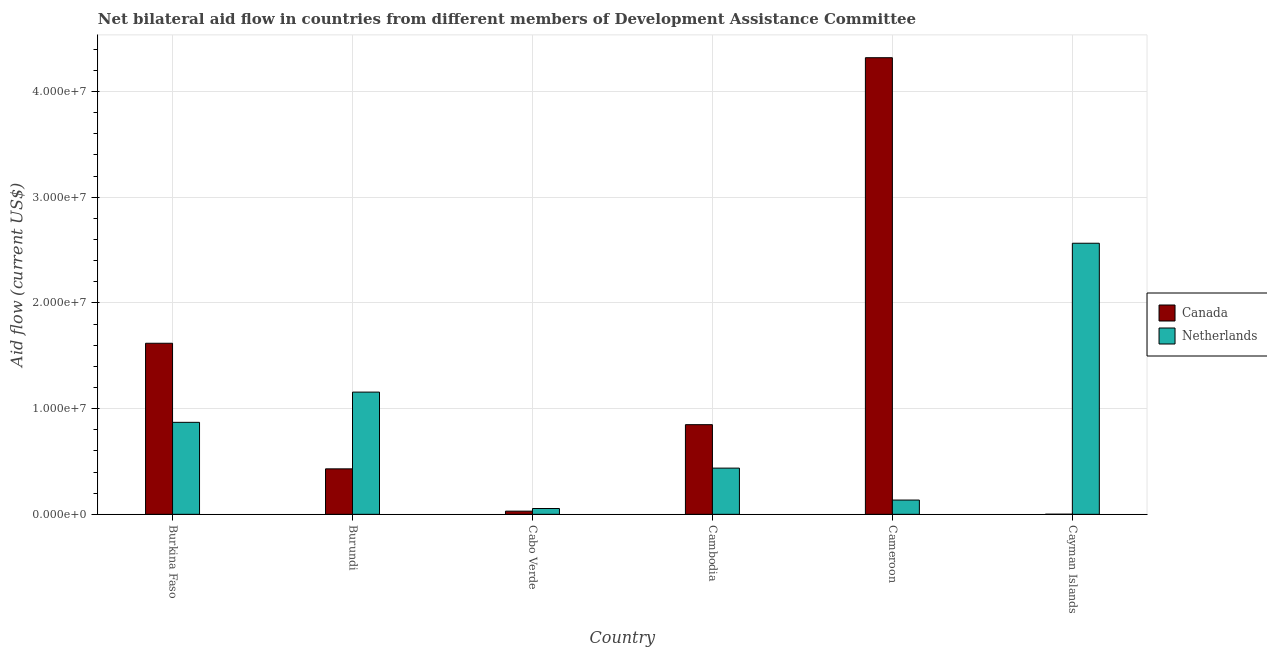How many different coloured bars are there?
Provide a succinct answer. 2. How many groups of bars are there?
Make the answer very short. 6. Are the number of bars per tick equal to the number of legend labels?
Give a very brief answer. Yes. Are the number of bars on each tick of the X-axis equal?
Your answer should be compact. Yes. What is the label of the 2nd group of bars from the left?
Provide a short and direct response. Burundi. What is the amount of aid given by netherlands in Cameroon?
Provide a short and direct response. 1.35e+06. Across all countries, what is the maximum amount of aid given by canada?
Give a very brief answer. 4.32e+07. Across all countries, what is the minimum amount of aid given by canada?
Offer a very short reply. 10000. In which country was the amount of aid given by canada maximum?
Make the answer very short. Cameroon. In which country was the amount of aid given by netherlands minimum?
Provide a short and direct response. Cabo Verde. What is the total amount of aid given by netherlands in the graph?
Make the answer very short. 5.22e+07. What is the difference between the amount of aid given by canada in Burkina Faso and that in Burundi?
Offer a terse response. 1.19e+07. What is the difference between the amount of aid given by canada in Burkina Faso and the amount of aid given by netherlands in Cabo Verde?
Offer a terse response. 1.56e+07. What is the average amount of aid given by netherlands per country?
Make the answer very short. 8.70e+06. What is the difference between the amount of aid given by netherlands and amount of aid given by canada in Burkina Faso?
Your answer should be very brief. -7.48e+06. What is the ratio of the amount of aid given by canada in Cambodia to that in Cameroon?
Give a very brief answer. 0.2. What is the difference between the highest and the second highest amount of aid given by canada?
Your answer should be very brief. 2.70e+07. What is the difference between the highest and the lowest amount of aid given by canada?
Your answer should be very brief. 4.32e+07. In how many countries, is the amount of aid given by canada greater than the average amount of aid given by canada taken over all countries?
Keep it short and to the point. 2. Is the sum of the amount of aid given by netherlands in Burkina Faso and Cambodia greater than the maximum amount of aid given by canada across all countries?
Keep it short and to the point. No. What does the 2nd bar from the left in Cayman Islands represents?
Make the answer very short. Netherlands. Are all the bars in the graph horizontal?
Provide a short and direct response. No. Are the values on the major ticks of Y-axis written in scientific E-notation?
Give a very brief answer. Yes. Does the graph contain any zero values?
Keep it short and to the point. No. Where does the legend appear in the graph?
Ensure brevity in your answer.  Center right. How many legend labels are there?
Make the answer very short. 2. What is the title of the graph?
Make the answer very short. Net bilateral aid flow in countries from different members of Development Assistance Committee. Does "Private consumption" appear as one of the legend labels in the graph?
Your answer should be compact. No. What is the label or title of the Y-axis?
Offer a terse response. Aid flow (current US$). What is the Aid flow (current US$) of Canada in Burkina Faso?
Give a very brief answer. 1.62e+07. What is the Aid flow (current US$) of Netherlands in Burkina Faso?
Offer a terse response. 8.70e+06. What is the Aid flow (current US$) of Canada in Burundi?
Provide a short and direct response. 4.30e+06. What is the Aid flow (current US$) in Netherlands in Burundi?
Ensure brevity in your answer.  1.16e+07. What is the Aid flow (current US$) of Canada in Cambodia?
Provide a short and direct response. 8.48e+06. What is the Aid flow (current US$) in Netherlands in Cambodia?
Provide a succinct answer. 4.37e+06. What is the Aid flow (current US$) of Canada in Cameroon?
Provide a short and direct response. 4.32e+07. What is the Aid flow (current US$) of Netherlands in Cameroon?
Provide a succinct answer. 1.35e+06. What is the Aid flow (current US$) of Netherlands in Cayman Islands?
Give a very brief answer. 2.56e+07. Across all countries, what is the maximum Aid flow (current US$) of Canada?
Keep it short and to the point. 4.32e+07. Across all countries, what is the maximum Aid flow (current US$) in Netherlands?
Offer a very short reply. 2.56e+07. What is the total Aid flow (current US$) in Canada in the graph?
Keep it short and to the point. 7.25e+07. What is the total Aid flow (current US$) in Netherlands in the graph?
Ensure brevity in your answer.  5.22e+07. What is the difference between the Aid flow (current US$) of Canada in Burkina Faso and that in Burundi?
Make the answer very short. 1.19e+07. What is the difference between the Aid flow (current US$) of Netherlands in Burkina Faso and that in Burundi?
Provide a short and direct response. -2.86e+06. What is the difference between the Aid flow (current US$) of Canada in Burkina Faso and that in Cabo Verde?
Give a very brief answer. 1.59e+07. What is the difference between the Aid flow (current US$) in Netherlands in Burkina Faso and that in Cabo Verde?
Ensure brevity in your answer.  8.15e+06. What is the difference between the Aid flow (current US$) in Canada in Burkina Faso and that in Cambodia?
Your response must be concise. 7.70e+06. What is the difference between the Aid flow (current US$) in Netherlands in Burkina Faso and that in Cambodia?
Offer a very short reply. 4.33e+06. What is the difference between the Aid flow (current US$) of Canada in Burkina Faso and that in Cameroon?
Ensure brevity in your answer.  -2.70e+07. What is the difference between the Aid flow (current US$) of Netherlands in Burkina Faso and that in Cameroon?
Provide a succinct answer. 7.35e+06. What is the difference between the Aid flow (current US$) in Canada in Burkina Faso and that in Cayman Islands?
Your answer should be compact. 1.62e+07. What is the difference between the Aid flow (current US$) in Netherlands in Burkina Faso and that in Cayman Islands?
Give a very brief answer. -1.69e+07. What is the difference between the Aid flow (current US$) of Netherlands in Burundi and that in Cabo Verde?
Offer a terse response. 1.10e+07. What is the difference between the Aid flow (current US$) in Canada in Burundi and that in Cambodia?
Make the answer very short. -4.18e+06. What is the difference between the Aid flow (current US$) of Netherlands in Burundi and that in Cambodia?
Your answer should be compact. 7.19e+06. What is the difference between the Aid flow (current US$) in Canada in Burundi and that in Cameroon?
Ensure brevity in your answer.  -3.89e+07. What is the difference between the Aid flow (current US$) in Netherlands in Burundi and that in Cameroon?
Your response must be concise. 1.02e+07. What is the difference between the Aid flow (current US$) of Canada in Burundi and that in Cayman Islands?
Give a very brief answer. 4.29e+06. What is the difference between the Aid flow (current US$) of Netherlands in Burundi and that in Cayman Islands?
Keep it short and to the point. -1.41e+07. What is the difference between the Aid flow (current US$) in Canada in Cabo Verde and that in Cambodia?
Provide a short and direct response. -8.18e+06. What is the difference between the Aid flow (current US$) in Netherlands in Cabo Verde and that in Cambodia?
Ensure brevity in your answer.  -3.82e+06. What is the difference between the Aid flow (current US$) in Canada in Cabo Verde and that in Cameroon?
Make the answer very short. -4.29e+07. What is the difference between the Aid flow (current US$) in Netherlands in Cabo Verde and that in Cameroon?
Your answer should be very brief. -8.00e+05. What is the difference between the Aid flow (current US$) of Netherlands in Cabo Verde and that in Cayman Islands?
Your answer should be compact. -2.51e+07. What is the difference between the Aid flow (current US$) in Canada in Cambodia and that in Cameroon?
Provide a short and direct response. -3.47e+07. What is the difference between the Aid flow (current US$) in Netherlands in Cambodia and that in Cameroon?
Offer a very short reply. 3.02e+06. What is the difference between the Aid flow (current US$) of Canada in Cambodia and that in Cayman Islands?
Offer a very short reply. 8.47e+06. What is the difference between the Aid flow (current US$) in Netherlands in Cambodia and that in Cayman Islands?
Your answer should be very brief. -2.13e+07. What is the difference between the Aid flow (current US$) in Canada in Cameroon and that in Cayman Islands?
Provide a short and direct response. 4.32e+07. What is the difference between the Aid flow (current US$) of Netherlands in Cameroon and that in Cayman Islands?
Offer a very short reply. -2.43e+07. What is the difference between the Aid flow (current US$) in Canada in Burkina Faso and the Aid flow (current US$) in Netherlands in Burundi?
Your response must be concise. 4.62e+06. What is the difference between the Aid flow (current US$) of Canada in Burkina Faso and the Aid flow (current US$) of Netherlands in Cabo Verde?
Your answer should be compact. 1.56e+07. What is the difference between the Aid flow (current US$) of Canada in Burkina Faso and the Aid flow (current US$) of Netherlands in Cambodia?
Your answer should be very brief. 1.18e+07. What is the difference between the Aid flow (current US$) of Canada in Burkina Faso and the Aid flow (current US$) of Netherlands in Cameroon?
Provide a short and direct response. 1.48e+07. What is the difference between the Aid flow (current US$) in Canada in Burkina Faso and the Aid flow (current US$) in Netherlands in Cayman Islands?
Provide a short and direct response. -9.46e+06. What is the difference between the Aid flow (current US$) of Canada in Burundi and the Aid flow (current US$) of Netherlands in Cabo Verde?
Your answer should be compact. 3.75e+06. What is the difference between the Aid flow (current US$) of Canada in Burundi and the Aid flow (current US$) of Netherlands in Cameroon?
Keep it short and to the point. 2.95e+06. What is the difference between the Aid flow (current US$) of Canada in Burundi and the Aid flow (current US$) of Netherlands in Cayman Islands?
Make the answer very short. -2.13e+07. What is the difference between the Aid flow (current US$) of Canada in Cabo Verde and the Aid flow (current US$) of Netherlands in Cambodia?
Give a very brief answer. -4.07e+06. What is the difference between the Aid flow (current US$) of Canada in Cabo Verde and the Aid flow (current US$) of Netherlands in Cameroon?
Offer a very short reply. -1.05e+06. What is the difference between the Aid flow (current US$) in Canada in Cabo Verde and the Aid flow (current US$) in Netherlands in Cayman Islands?
Give a very brief answer. -2.53e+07. What is the difference between the Aid flow (current US$) in Canada in Cambodia and the Aid flow (current US$) in Netherlands in Cameroon?
Your answer should be compact. 7.13e+06. What is the difference between the Aid flow (current US$) of Canada in Cambodia and the Aid flow (current US$) of Netherlands in Cayman Islands?
Ensure brevity in your answer.  -1.72e+07. What is the difference between the Aid flow (current US$) in Canada in Cameroon and the Aid flow (current US$) in Netherlands in Cayman Islands?
Provide a short and direct response. 1.76e+07. What is the average Aid flow (current US$) of Canada per country?
Your response must be concise. 1.21e+07. What is the average Aid flow (current US$) in Netherlands per country?
Ensure brevity in your answer.  8.70e+06. What is the difference between the Aid flow (current US$) of Canada and Aid flow (current US$) of Netherlands in Burkina Faso?
Offer a terse response. 7.48e+06. What is the difference between the Aid flow (current US$) in Canada and Aid flow (current US$) in Netherlands in Burundi?
Make the answer very short. -7.26e+06. What is the difference between the Aid flow (current US$) of Canada and Aid flow (current US$) of Netherlands in Cabo Verde?
Offer a terse response. -2.50e+05. What is the difference between the Aid flow (current US$) of Canada and Aid flow (current US$) of Netherlands in Cambodia?
Offer a very short reply. 4.11e+06. What is the difference between the Aid flow (current US$) of Canada and Aid flow (current US$) of Netherlands in Cameroon?
Give a very brief answer. 4.18e+07. What is the difference between the Aid flow (current US$) of Canada and Aid flow (current US$) of Netherlands in Cayman Islands?
Make the answer very short. -2.56e+07. What is the ratio of the Aid flow (current US$) of Canada in Burkina Faso to that in Burundi?
Offer a very short reply. 3.76. What is the ratio of the Aid flow (current US$) in Netherlands in Burkina Faso to that in Burundi?
Offer a terse response. 0.75. What is the ratio of the Aid flow (current US$) in Canada in Burkina Faso to that in Cabo Verde?
Your answer should be compact. 53.93. What is the ratio of the Aid flow (current US$) of Netherlands in Burkina Faso to that in Cabo Verde?
Your answer should be very brief. 15.82. What is the ratio of the Aid flow (current US$) in Canada in Burkina Faso to that in Cambodia?
Provide a short and direct response. 1.91. What is the ratio of the Aid flow (current US$) of Netherlands in Burkina Faso to that in Cambodia?
Keep it short and to the point. 1.99. What is the ratio of the Aid flow (current US$) in Canada in Burkina Faso to that in Cameroon?
Give a very brief answer. 0.37. What is the ratio of the Aid flow (current US$) of Netherlands in Burkina Faso to that in Cameroon?
Provide a succinct answer. 6.44. What is the ratio of the Aid flow (current US$) of Canada in Burkina Faso to that in Cayman Islands?
Your answer should be compact. 1618. What is the ratio of the Aid flow (current US$) of Netherlands in Burkina Faso to that in Cayman Islands?
Offer a terse response. 0.34. What is the ratio of the Aid flow (current US$) of Canada in Burundi to that in Cabo Verde?
Offer a terse response. 14.33. What is the ratio of the Aid flow (current US$) in Netherlands in Burundi to that in Cabo Verde?
Provide a succinct answer. 21.02. What is the ratio of the Aid flow (current US$) of Canada in Burundi to that in Cambodia?
Your answer should be very brief. 0.51. What is the ratio of the Aid flow (current US$) of Netherlands in Burundi to that in Cambodia?
Keep it short and to the point. 2.65. What is the ratio of the Aid flow (current US$) of Canada in Burundi to that in Cameroon?
Make the answer very short. 0.1. What is the ratio of the Aid flow (current US$) of Netherlands in Burundi to that in Cameroon?
Your answer should be very brief. 8.56. What is the ratio of the Aid flow (current US$) of Canada in Burundi to that in Cayman Islands?
Offer a terse response. 430. What is the ratio of the Aid flow (current US$) of Netherlands in Burundi to that in Cayman Islands?
Your response must be concise. 0.45. What is the ratio of the Aid flow (current US$) in Canada in Cabo Verde to that in Cambodia?
Your answer should be compact. 0.04. What is the ratio of the Aid flow (current US$) of Netherlands in Cabo Verde to that in Cambodia?
Your answer should be compact. 0.13. What is the ratio of the Aid flow (current US$) in Canada in Cabo Verde to that in Cameroon?
Your answer should be very brief. 0.01. What is the ratio of the Aid flow (current US$) in Netherlands in Cabo Verde to that in Cameroon?
Your answer should be very brief. 0.41. What is the ratio of the Aid flow (current US$) of Netherlands in Cabo Verde to that in Cayman Islands?
Make the answer very short. 0.02. What is the ratio of the Aid flow (current US$) in Canada in Cambodia to that in Cameroon?
Your answer should be very brief. 0.2. What is the ratio of the Aid flow (current US$) of Netherlands in Cambodia to that in Cameroon?
Keep it short and to the point. 3.24. What is the ratio of the Aid flow (current US$) in Canada in Cambodia to that in Cayman Islands?
Offer a terse response. 848. What is the ratio of the Aid flow (current US$) in Netherlands in Cambodia to that in Cayman Islands?
Your response must be concise. 0.17. What is the ratio of the Aid flow (current US$) of Canada in Cameroon to that in Cayman Islands?
Your response must be concise. 4319. What is the ratio of the Aid flow (current US$) of Netherlands in Cameroon to that in Cayman Islands?
Offer a terse response. 0.05. What is the difference between the highest and the second highest Aid flow (current US$) in Canada?
Give a very brief answer. 2.70e+07. What is the difference between the highest and the second highest Aid flow (current US$) in Netherlands?
Provide a succinct answer. 1.41e+07. What is the difference between the highest and the lowest Aid flow (current US$) of Canada?
Give a very brief answer. 4.32e+07. What is the difference between the highest and the lowest Aid flow (current US$) in Netherlands?
Your answer should be very brief. 2.51e+07. 